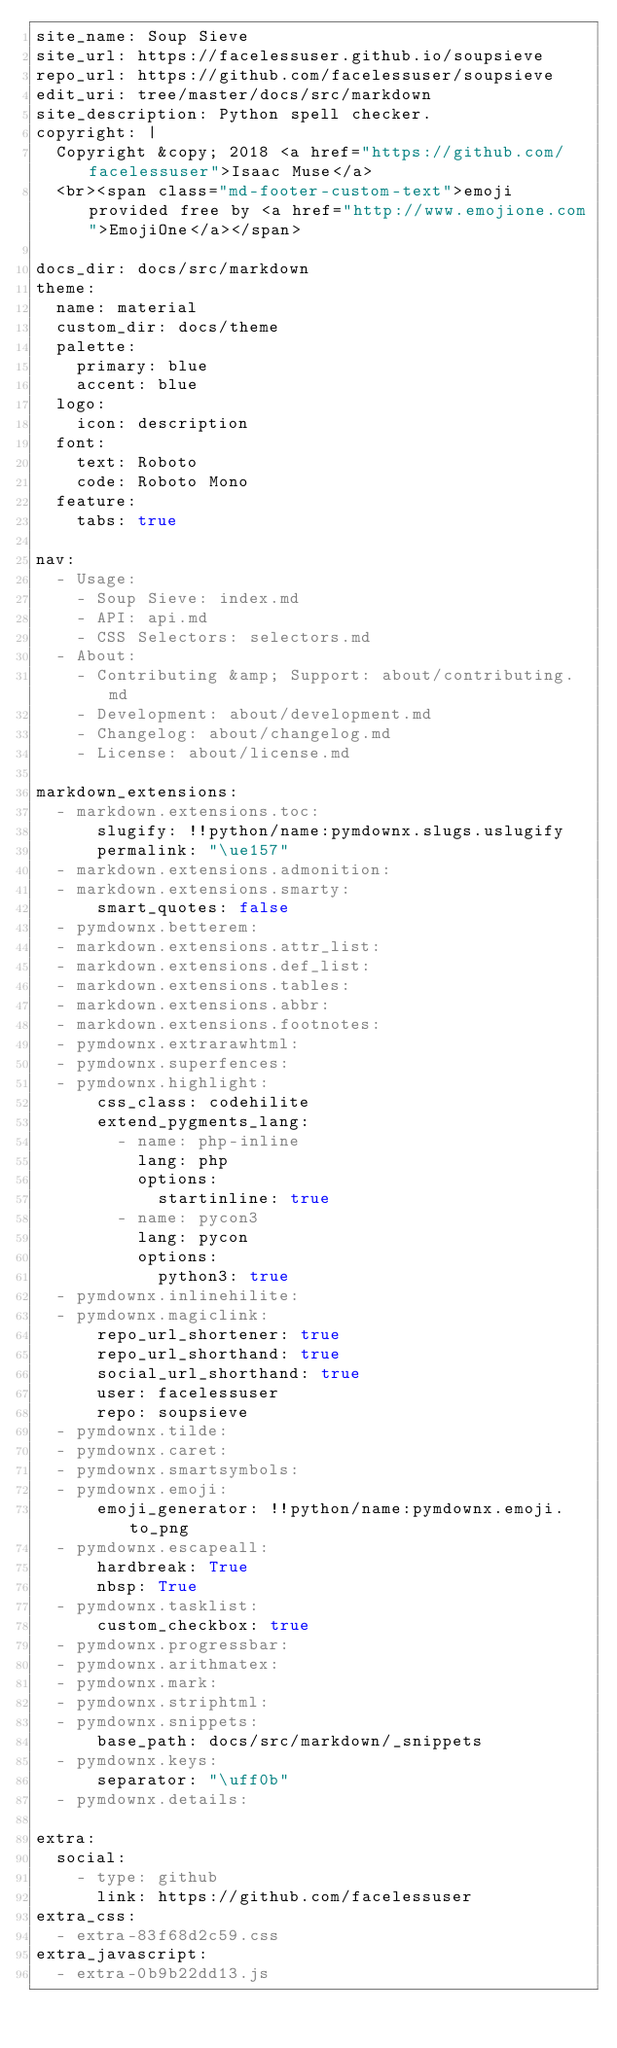Convert code to text. <code><loc_0><loc_0><loc_500><loc_500><_YAML_>site_name: Soup Sieve
site_url: https://facelessuser.github.io/soupsieve
repo_url: https://github.com/facelessuser/soupsieve
edit_uri: tree/master/docs/src/markdown
site_description: Python spell checker.
copyright: |
  Copyright &copy; 2018 <a href="https://github.com/facelessuser">Isaac Muse</a>
  <br><span class="md-footer-custom-text">emoji provided free by <a href="http://www.emojione.com">EmojiOne</a></span>

docs_dir: docs/src/markdown
theme:
  name: material
  custom_dir: docs/theme
  palette:
    primary: blue
    accent: blue
  logo:
    icon: description
  font:
    text: Roboto
    code: Roboto Mono
  feature:
    tabs: true

nav:
  - Usage:
    - Soup Sieve: index.md
    - API: api.md
    - CSS Selectors: selectors.md
  - About:
    - Contributing &amp; Support: about/contributing.md
    - Development: about/development.md
    - Changelog: about/changelog.md
    - License: about/license.md

markdown_extensions:
  - markdown.extensions.toc:
      slugify: !!python/name:pymdownx.slugs.uslugify
      permalink: "\ue157"
  - markdown.extensions.admonition:
  - markdown.extensions.smarty:
      smart_quotes: false
  - pymdownx.betterem:
  - markdown.extensions.attr_list:
  - markdown.extensions.def_list:
  - markdown.extensions.tables:
  - markdown.extensions.abbr:
  - markdown.extensions.footnotes:
  - pymdownx.extrarawhtml:
  - pymdownx.superfences:
  - pymdownx.highlight:
      css_class: codehilite
      extend_pygments_lang:
        - name: php-inline
          lang: php
          options:
            startinline: true
        - name: pycon3
          lang: pycon
          options:
            python3: true
  - pymdownx.inlinehilite:
  - pymdownx.magiclink:
      repo_url_shortener: true
      repo_url_shorthand: true
      social_url_shorthand: true
      user: facelessuser
      repo: soupsieve
  - pymdownx.tilde:
  - pymdownx.caret:
  - pymdownx.smartsymbols:
  - pymdownx.emoji:
      emoji_generator: !!python/name:pymdownx.emoji.to_png
  - pymdownx.escapeall:
      hardbreak: True
      nbsp: True
  - pymdownx.tasklist:
      custom_checkbox: true
  - pymdownx.progressbar:
  - pymdownx.arithmatex:
  - pymdownx.mark:
  - pymdownx.striphtml:
  - pymdownx.snippets:
      base_path: docs/src/markdown/_snippets
  - pymdownx.keys:
      separator: "\uff0b"
  - pymdownx.details:

extra:
  social:
    - type: github
      link: https://github.com/facelessuser
extra_css:
  - extra-83f68d2c59.css
extra_javascript:
  - extra-0b9b22dd13.js
</code> 